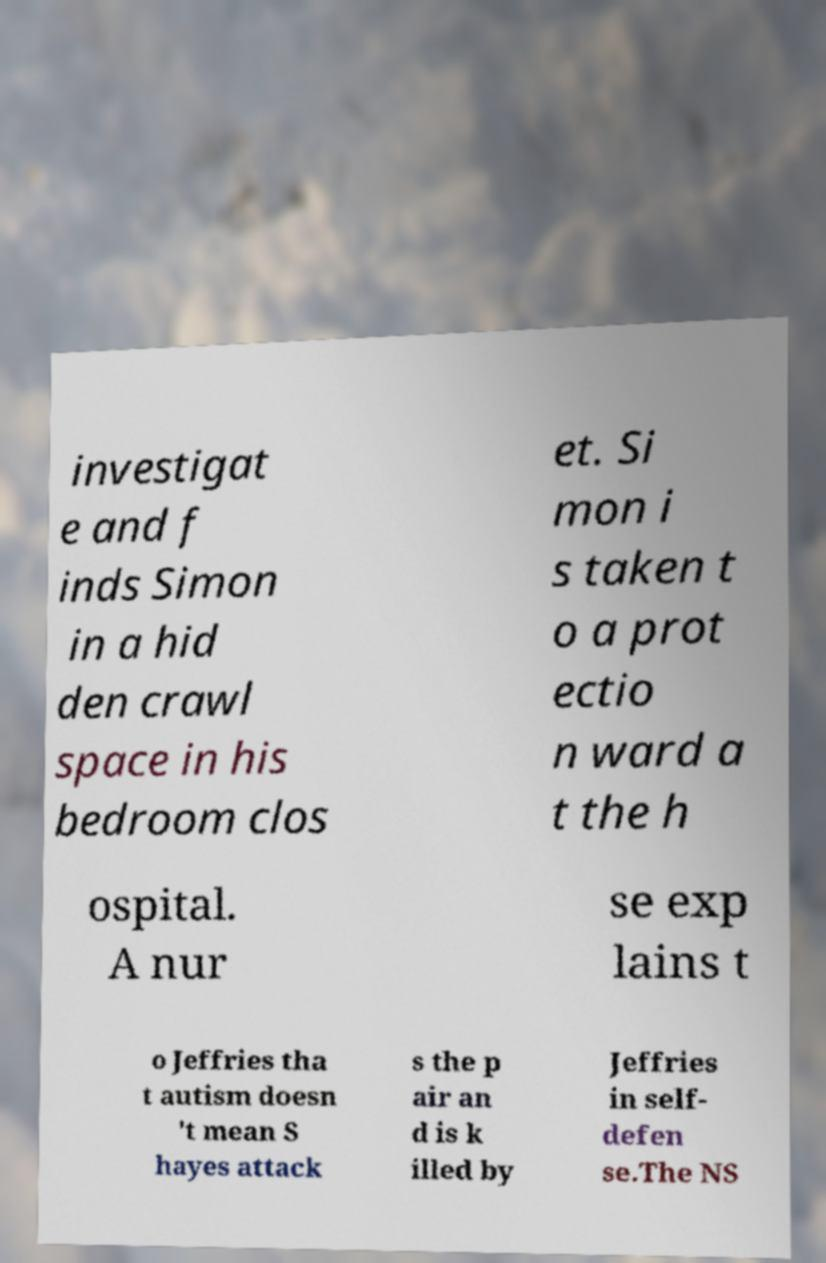Could you assist in decoding the text presented in this image and type it out clearly? investigat e and f inds Simon in a hid den crawl space in his bedroom clos et. Si mon i s taken t o a prot ectio n ward a t the h ospital. A nur se exp lains t o Jeffries tha t autism doesn 't mean S hayes attack s the p air an d is k illed by Jeffries in self- defen se.The NS 